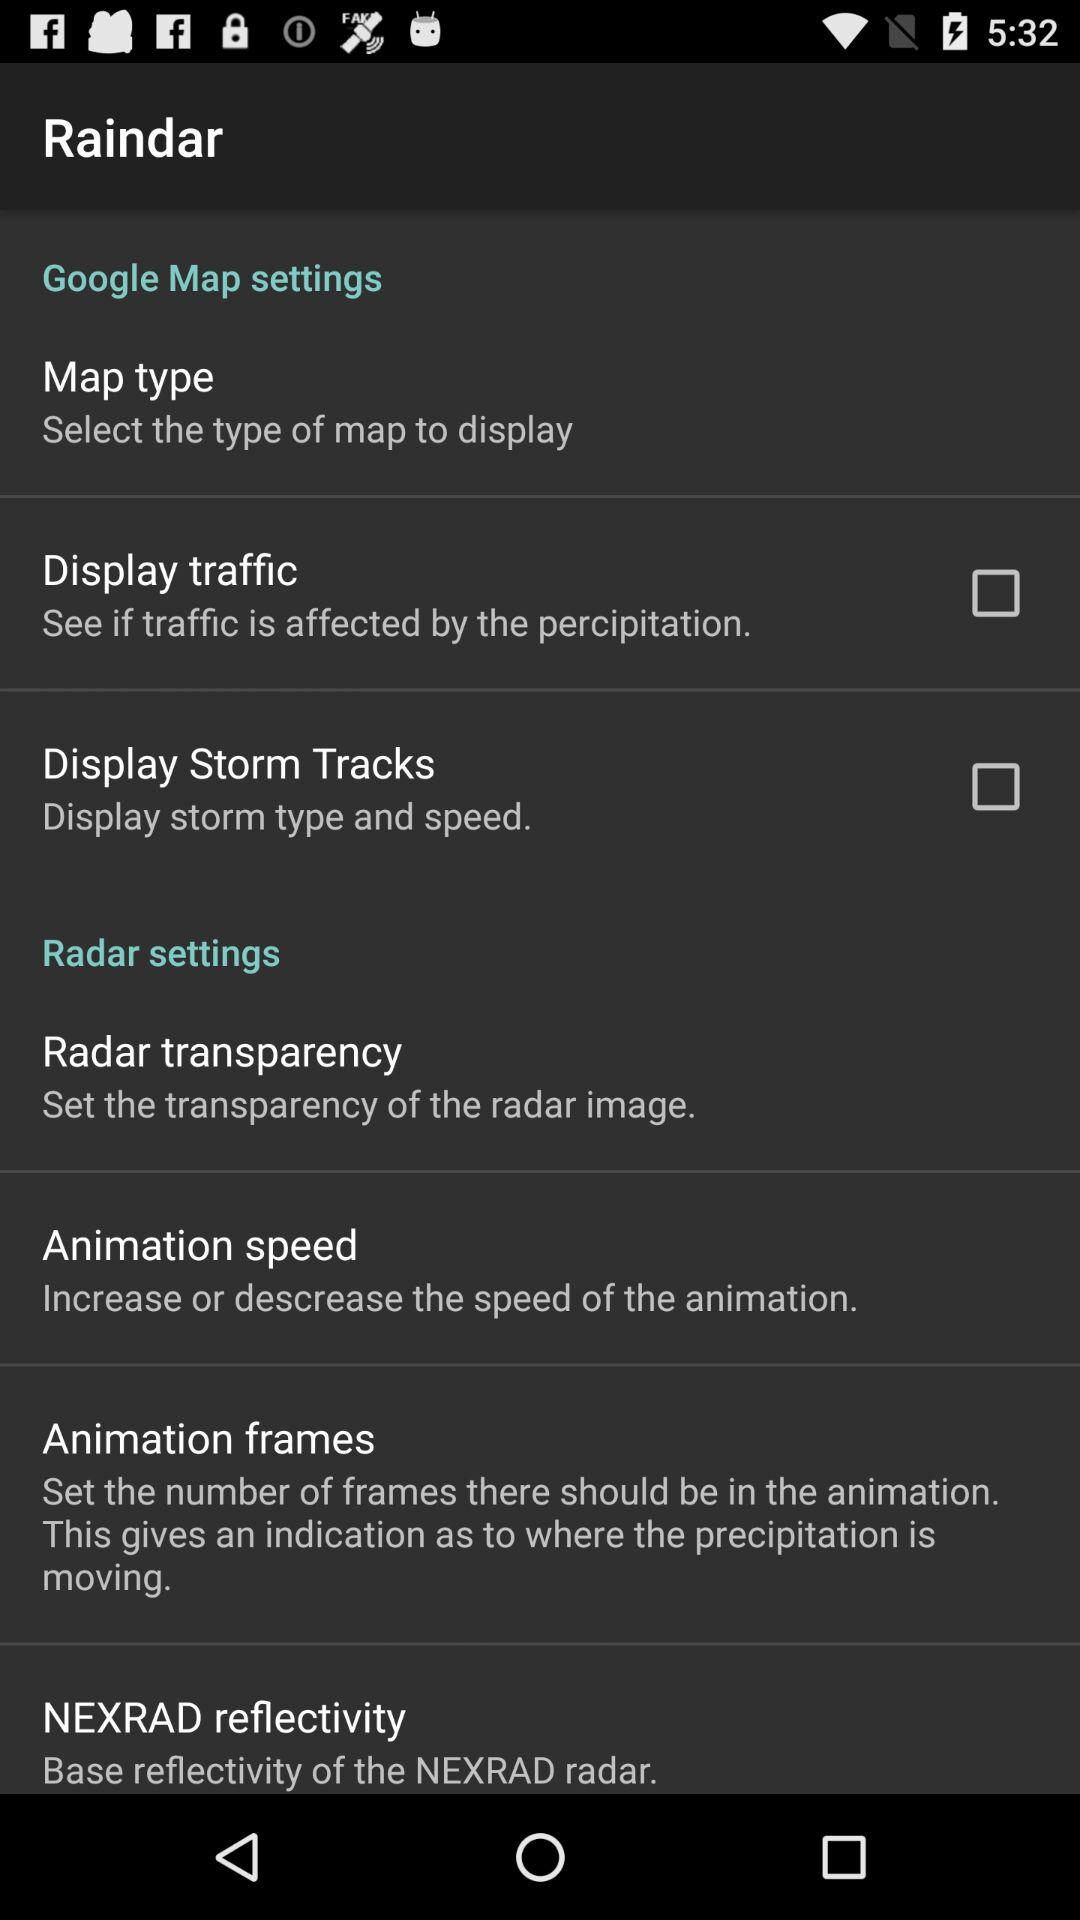What is the status of "Display traffic"? The status is "off". 